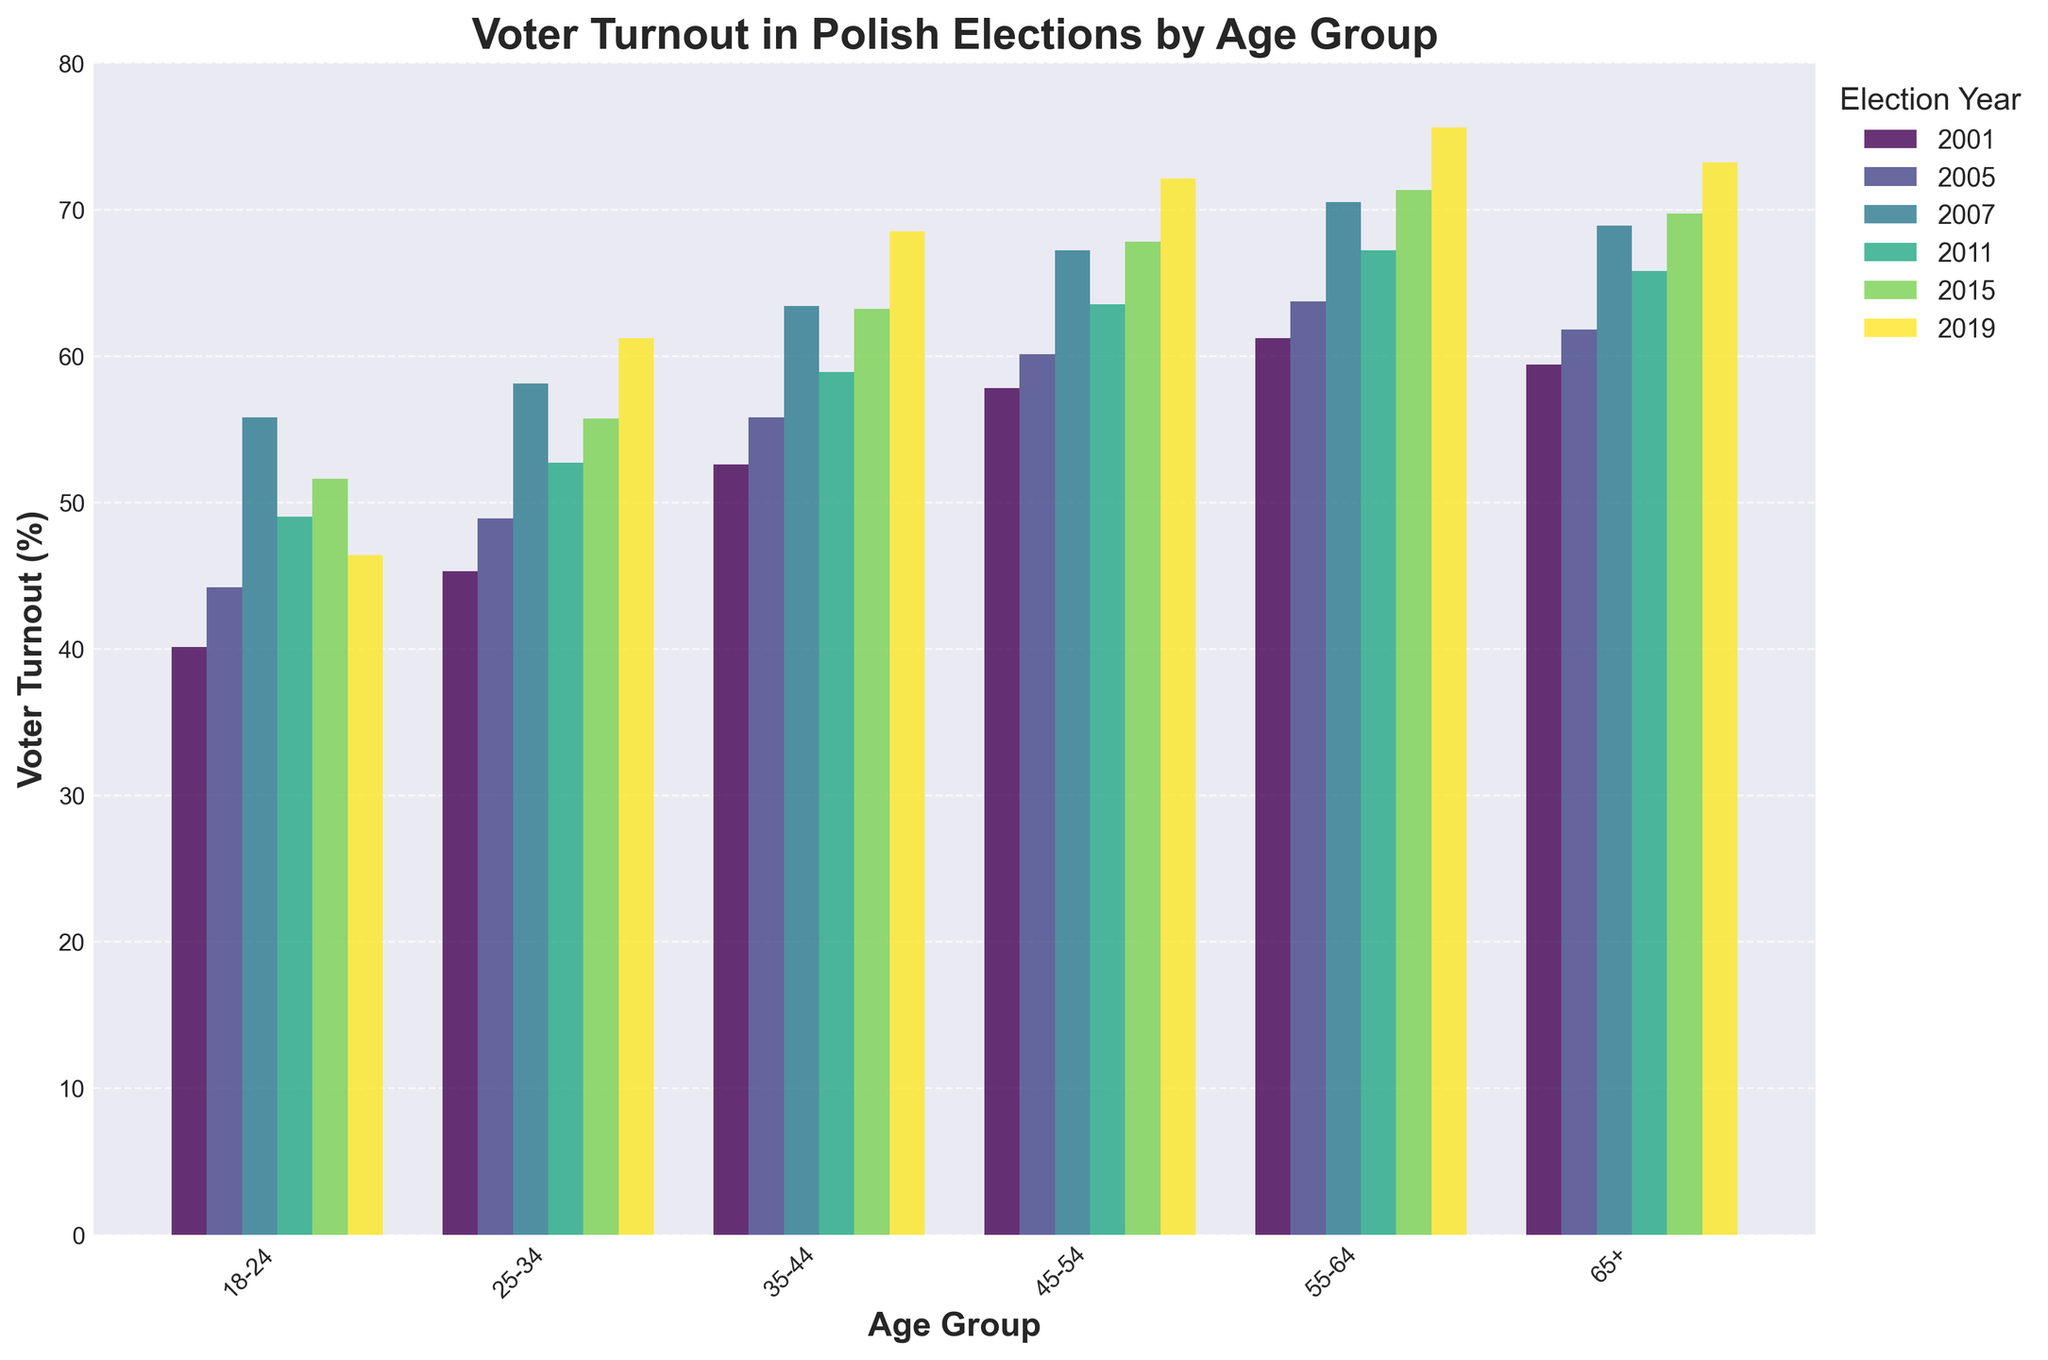What age group had the highest voter turnout in 2019? By looking at the bar for each age group in the year 2019, the 55-64 age group has the highest bar. Thus, they had the highest voter turnout.
Answer: 55-64 How did voter turnout change for the 18-24 age group from 2001 to 2019? Check the bar height for the 18-24 age group in 2001 and 2019. In 2001, it was 40.1%, and in 2019 it was 46.4%. Calculate the difference: 46.4% - 40.1% = 6.3%. Thus, the voter turnout increased by 6.3%.
Answer: Increased by 6.3% Which age group consistently had the highest voter turnout over the years? For each year, compare the bars. The 55-64 age group consistently has the highest bars for most years.
Answer: 55-64 What is the average voter turnout of the 35-44 age group over the 6 elections? Add the percentages for the 35-44 age group across all years: 52.6 + 55.8 + 63.4 + 58.9 + 63.2 + 68.5. Then divide by 6: (52.6 + 55.8 + 63.4 + 58.9 + 63.2 + 68.5) / 6 = 60.4%
Answer: 60.4% Between 45-54 and 65+, which age group had a larger increase in voter turnout from 2001 to 2019? Calculate the difference for each age group. For 45-54: 72.1% (2019) - 57.8% (2001) = 14.3%. For 65+: 73.2% (2019) - 59.4% (2001) = 13.8%. The 45-54 group had a larger increase.
Answer: 45-54 Which election year observed the largest voter turnout for the 25-34 age group? Identify the tallest bar for the 25-34 age group. The tallest bar, which indicates the largest turnout, is in 2019 with 61.2%.
Answer: 2019 Did voter turnout for 55-64 always increase in every election year depicted? Examine the bar heights for the 55-64 age group across the years. The bars increase each year, indicating a consistent rise in voter turnout.
Answer: Yes What is the difference in voter turnout between the youngest and oldest age groups in 2015? Compare the values for 18-24 and 65+ in 2015. The 18-24 turnout is 51.6%, and the 65+ turnout is 69.7%. Subtract 51.6 from 69.7 to get 18.1%.
Answer: 18.1% Which age group saw the smallest increase in voter turnout from 2001 to 2019? Calculate the differences for each age group from 2001 to 2019 and find the smallest one. The smallest difference is for the 65+ age group: 73.2% (2019) - 59.4% (2001) = 13.8%.
Answer: 65+ How does the voter turnout trend of the 35-44 age group compare with the 45-54 age group over the period? Look at the pattern of increasing heights of bars for each age group. Both age groups show a general upward trend, but the 45-54 age group's bars consistently are slightly higher than the 35-44 age group's bars.
Answer: 45-54 higher 